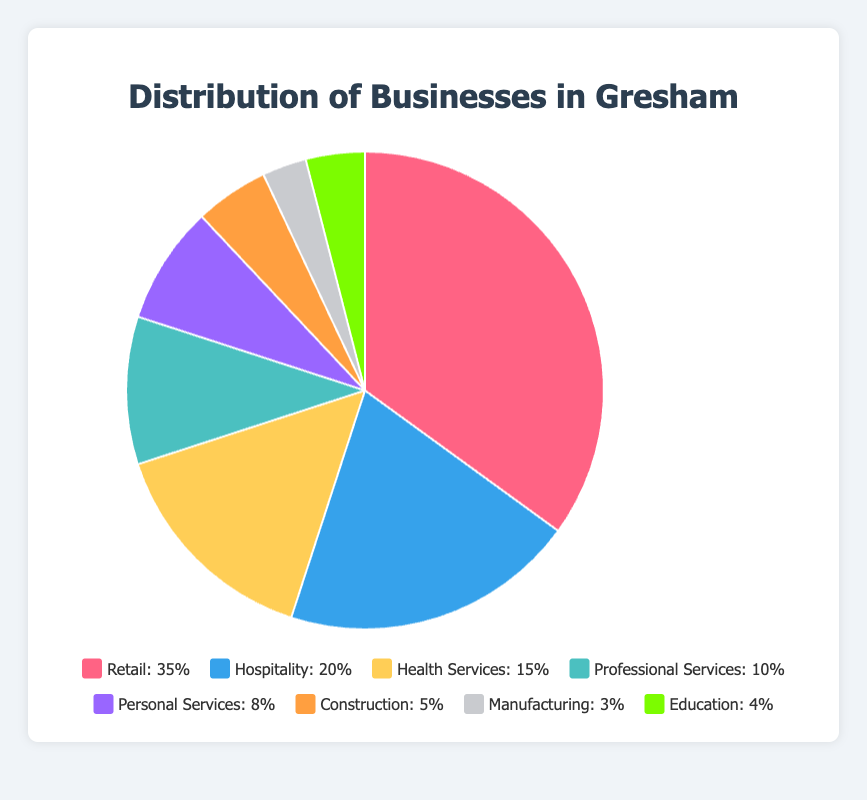What type of business has the highest percentage distribution in Gresham? The highest percentage distribution is provided by the category with the largest slice of the pie chart. Retail has the largest slice.
Answer: Retail Which two types of businesses together make up more than half of the distribution in Gresham? Adding the largest and the second largest categories gives their combined percentage. Retail is 35% and Hospitality is 20%, together they make 55%.
Answer: Retail and Hospitality What is the difference in percentage between Retail and Hospitality businesses? Subtract the percentage of Hospitality from the percentage of Retail. 35% - 20% = 15%.
Answer: 15% How does the percentage of Professional Services compare to that of Personal Services? Compare the percentages of Professional Services (10%) and Personal Services (8%). Since 10% is greater than 8%, Professional Services has a higher percentage than Personal Services.
Answer: Higher What is the combined percentage of Construction, Manufacturing, and Education businesses? Sum the percentages of Construction, Manufacturing, and Education. 5% + 3% + 4% = 12%.
Answer: 12% What color represents the Health Services section in the pie chart? The legend indicates each slice's color. Health Services is represented by the yellow section.
Answer: Yellow What average percentage of businesses do the categories of Construction and Manufacturing represent? Add the percentages of Construction (5%) and Manufacturing (3%) and divide by 2. (5% + 3%) / 2 = 4%.
Answer: 4% Which business type has the smallest percentage distribution, and what is that percentage? The smallest slice represents the business type with the lowest percentage. Manufacturing is the smallest, with a distribution of 3%.
Answer: Manufacturing with 3% If you combine the percentages of Personal Services and Health Services, is it greater than or less than Hospitality? Sum the percentages of Personal Services and Health Services and compare with Hospitality. Personal Services (8%) + Health Services (15%) = 23%, which is greater than Hospitality (20%).
Answer: Greater than What is the percentage difference between Education and Construction businesses? Subtract the percentage of Construction from that of Education. 4% - 5% = -1% (which means Construction is 1% higher).
Answer: 1% 